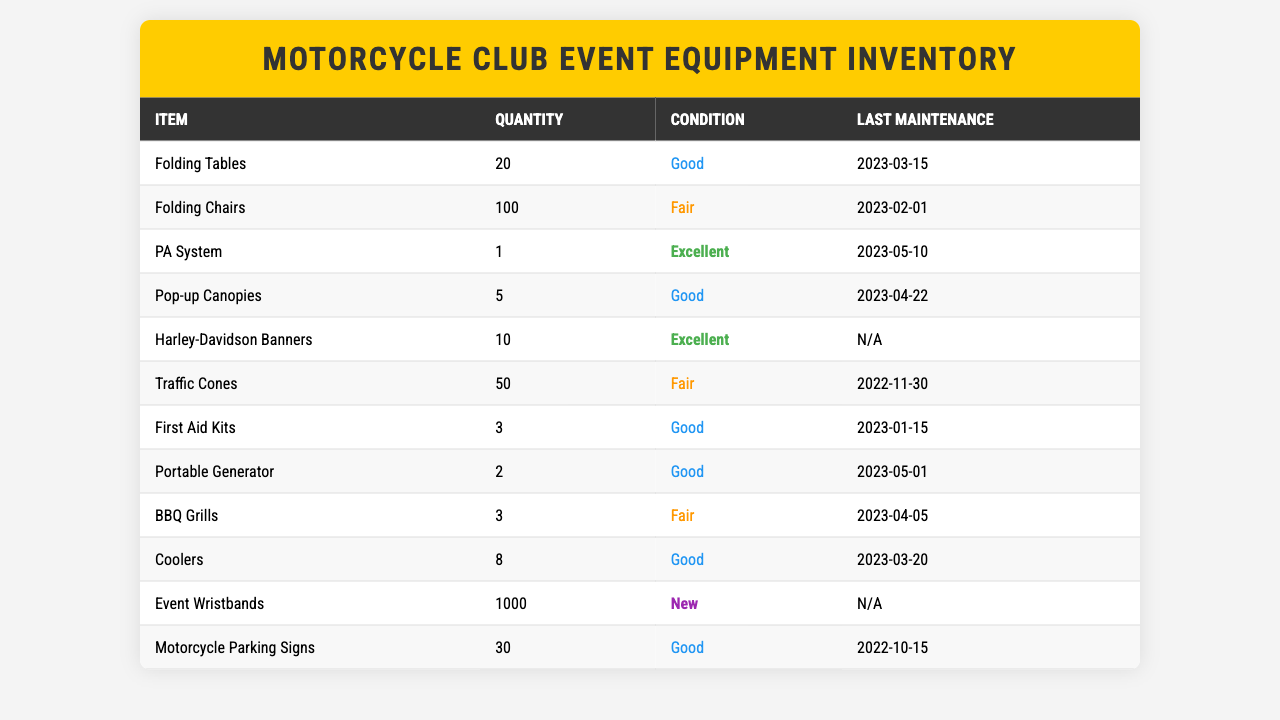What is the quantity of Folding Chairs owned by the motorcycle club? The table lists the Folding Chairs under the item column and shows a quantity of 100 next to it.
Answer: 100 What is the condition of the Portable Generator? By checking the condition column in the table, the Portable Generator is listed as "Good."
Answer: Good How many items in total are in the inventory? To determine the total items, we count the number of rows in the table, which shows 12 different items.
Answer: 12 Which equipment has the last maintenance date of 2023-05-01? Looking at the last maintenance column, the item with that date is the Portable Generator.
Answer: Portable Generator How many items are in "Fair" condition? The table shows three items marked as "Fair" – Folding Chairs, Traffic Cones, and BBQ Grills, giving a total of 3 items in that condition.
Answer: 3 Is there any equipment with "New" condition? The table indicates that there are Event Wristbands that are marked as "New."
Answer: Yes What is the total quantity of First Aid Kits and BBQ Grills? The quantity of First Aid Kits is listed as 3 and BBQ Grills as 3, summing them gives 3 + 3 = 6.
Answer: 6 What percentage of the total equipment is in "Excellent" condition? There are 2 items in "Excellent" condition (PA System and Harley-Davidson Banners) out of 12 total items. Therefore, the percentage is (2/12) * 100 = 16.67%.
Answer: 16.67% How many more Folding Chairs are there compared to Folding Tables? The table shows 100 Folding Chairs and 20 Folding Tables. To find the difference: 100 - 20 = 80.
Answer: 80 Which item has not had maintenance recorded as of yet? The table indicates that the Harley-Davidson Banners have "N/A" for the last maintenance date, meaning no maintenance has been recorded.
Answer: Harley-Davidson Banners 